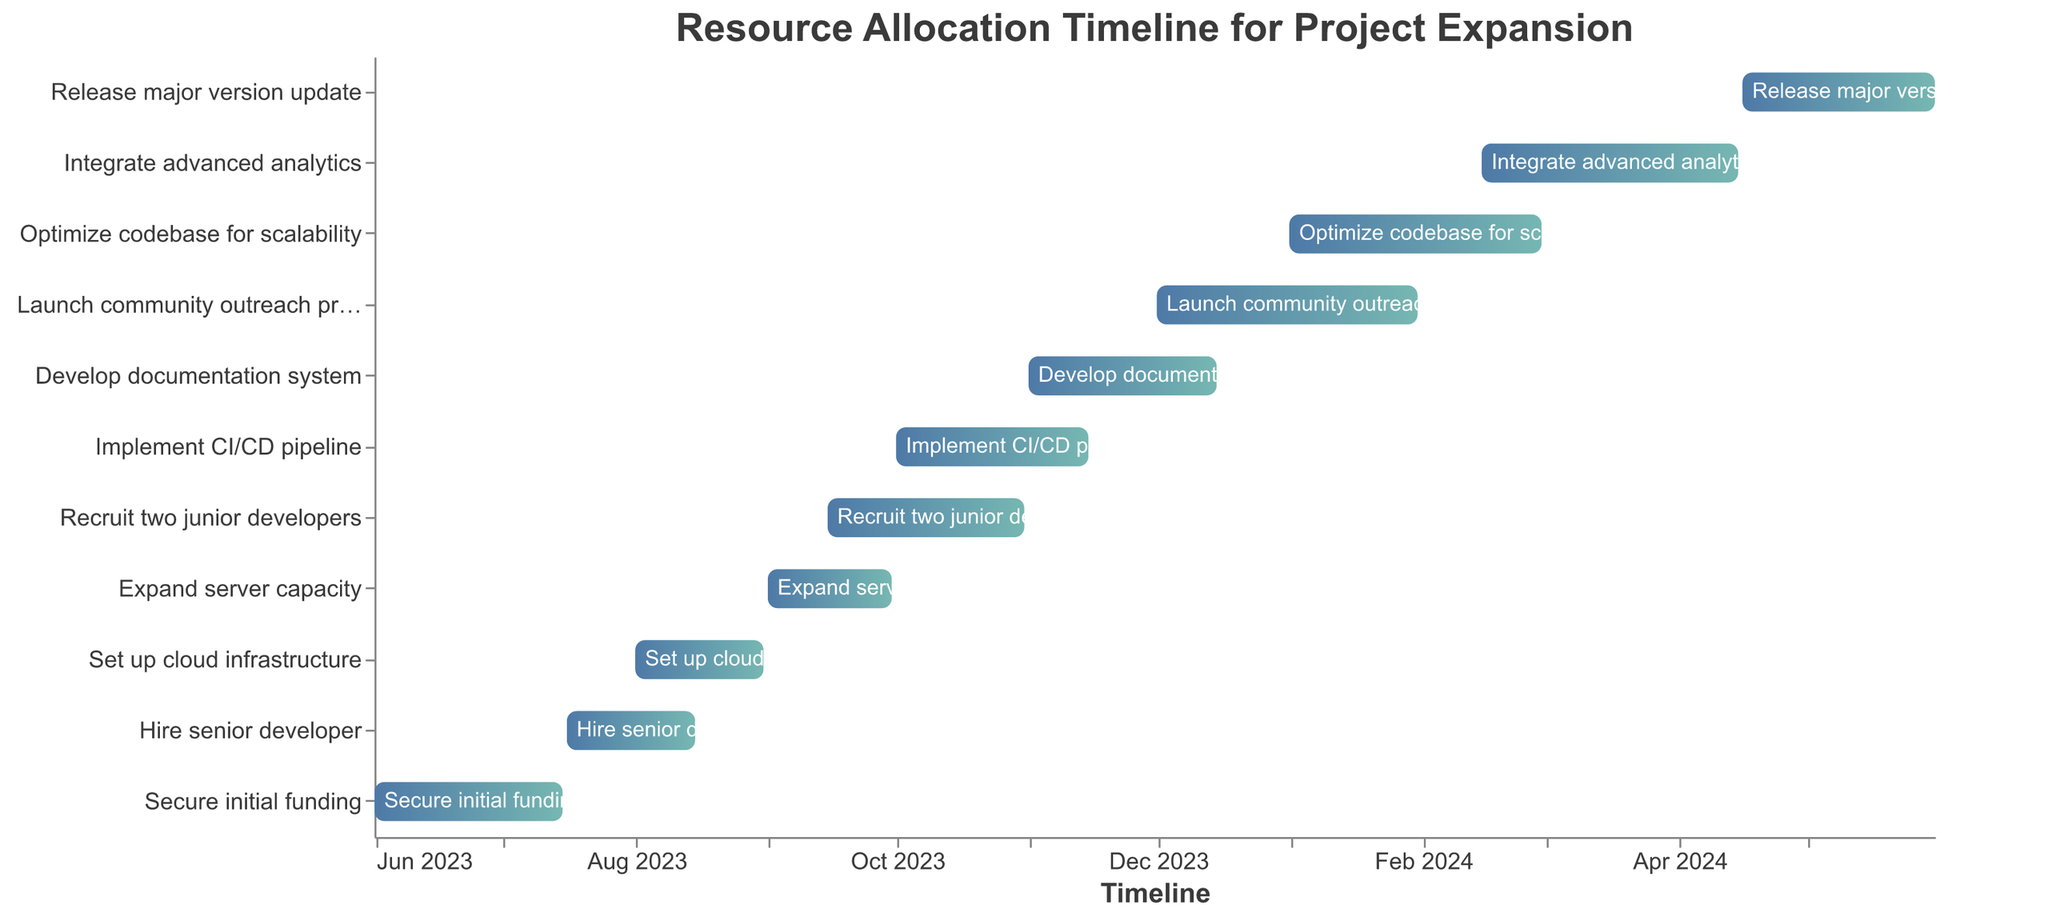What's the title of the Gantt chart? The title of the Gantt chart is typically displayed at the top of the figure. Here, it can be found at the top center in a larger font compared to other text in the chart.
Answer: Resource Allocation Timeline for Project Expansion What is the first task listed in the Gantt chart? The first task listed is the one that appears at the top of the y-axis, which is sorted by the start date in descending order.
Answer: Secure initial funding When does the task "Implement CI/CD pipeline" start and end? To find the start and end dates of a task, locate the task on the y-axis and then refer to the corresponding start and end points on the x-axis.
Answer: It starts on 2023-10-01 and ends on 2023-11-15 Which task has the longest duration and what is that duration? The duration of a task is the difference between its start and end dates. "Release major version update" spans from 2024-04-16 to 2024-05-31 which is 46 days, making it the longest task considering the formatting of this code.
Answer: Release major version update, 46 days What requirements overlap with setting up cloud infrastructure? To determine overlapping tasks, examine if the date ranges intersect on the Gantt chart. "Set up cloud infrastructure" runs from 2023-08-01 to 2023-08-31. The overlapping task "Hire senior developer" runs from 2023-07-16 to 2023-08-15.
Answer: Hire senior developer How many tasks are scheduled to start in the year 2024? Look for tasks with start dates in 2024 and count them. These tasks are: "Optimize codebase for scalability," "Integrate advanced analytics," and "Release major version update."
Answer: 3 tasks What tasks are planned after "Launch community outreach program"? Tasks that start after the end date of "Launch community outreach program" (2024-01-31) are "Optimize codebase for scalability," "Integrate advanced analytics," and "Release major version update."
Answer: Optimize codebase for scalability, Integrate advanced analytics, Release major version update List all tasks scheduled for Q4 2023 (October to December 2023). Tasks are within Q4 2023 if they have start and/or end dates from October to December 2023. "Recruit two junior developers," "Implement CI/CD pipeline," and "Develop documentation system" fall into this period.
Answer: Recruit two junior developers, Implement CI/CD pipeline, Develop documentation system Which tasks have start dates in the same month? Identify tasks with the same starting month. "Set up cloud infrastructure" and "Expand server capacity" both start in August 2023. "Integrate advanced analytics" and "Optimize codebase for scalability" start in February 2024.
Answer: Set up cloud infrastructure and Expand server capacity, Integrate advanced analytics and Optimize codebase for scalability What is the total duration from the start of "Secure initial funding" to the end of "Release major version update"? To find the total duration, calculate the difference between the start date of the earliest task and the end date of the latest task. The total duration is from 2023-06-01 to 2024-05-31, which includes 12 months.
Answer: 12 months 